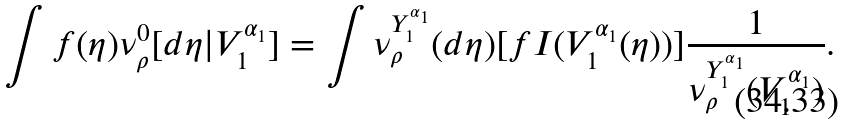Convert formula to latex. <formula><loc_0><loc_0><loc_500><loc_500>\int f ( \eta ) \nu ^ { 0 } _ { \rho } [ d \eta | V ^ { \alpha _ { 1 } } _ { 1 } ] = \int \nu ^ { Y ^ { \alpha _ { 1 } } _ { 1 } } _ { \rho } ( d \eta ) [ f I ( V ^ { \alpha _ { 1 } } _ { 1 } ( \eta ) ) ] \frac { 1 } { \nu _ { \rho } ^ { Y ^ { \alpha _ { 1 } } _ { 1 } } ( V ^ { \alpha _ { 1 } } _ { 1 } ) } .</formula> 